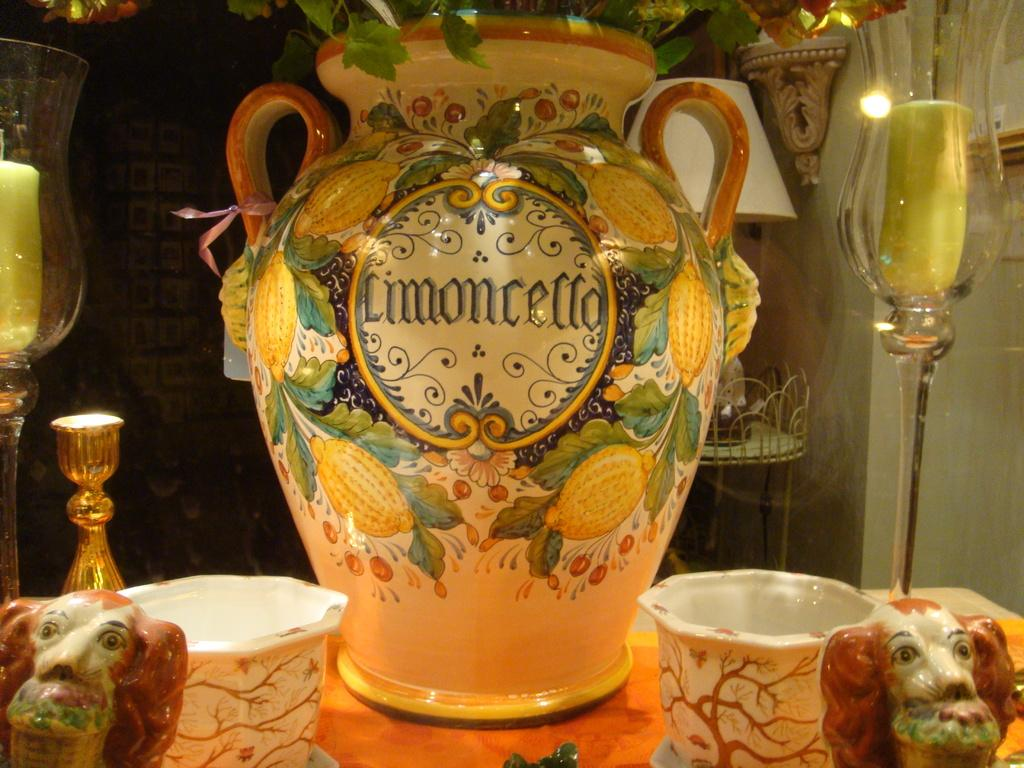What type of object is the main subject of the image? There is a big ceramic pot in the image. What other ceramic objects can be seen in the image? There are ceramic bowls and ceramic toys in the image. What is placed on the table in the image? Candles in glasses are present on a table in the image. What can be seen in the background of the image? There is a lamp and a wall in the background of the image. What is the purpose of the porter in the image? There is no porter present in the image. What type of journey is depicted in the image? The image does not depict a journey; it features ceramic objects and a lamp in the background. 